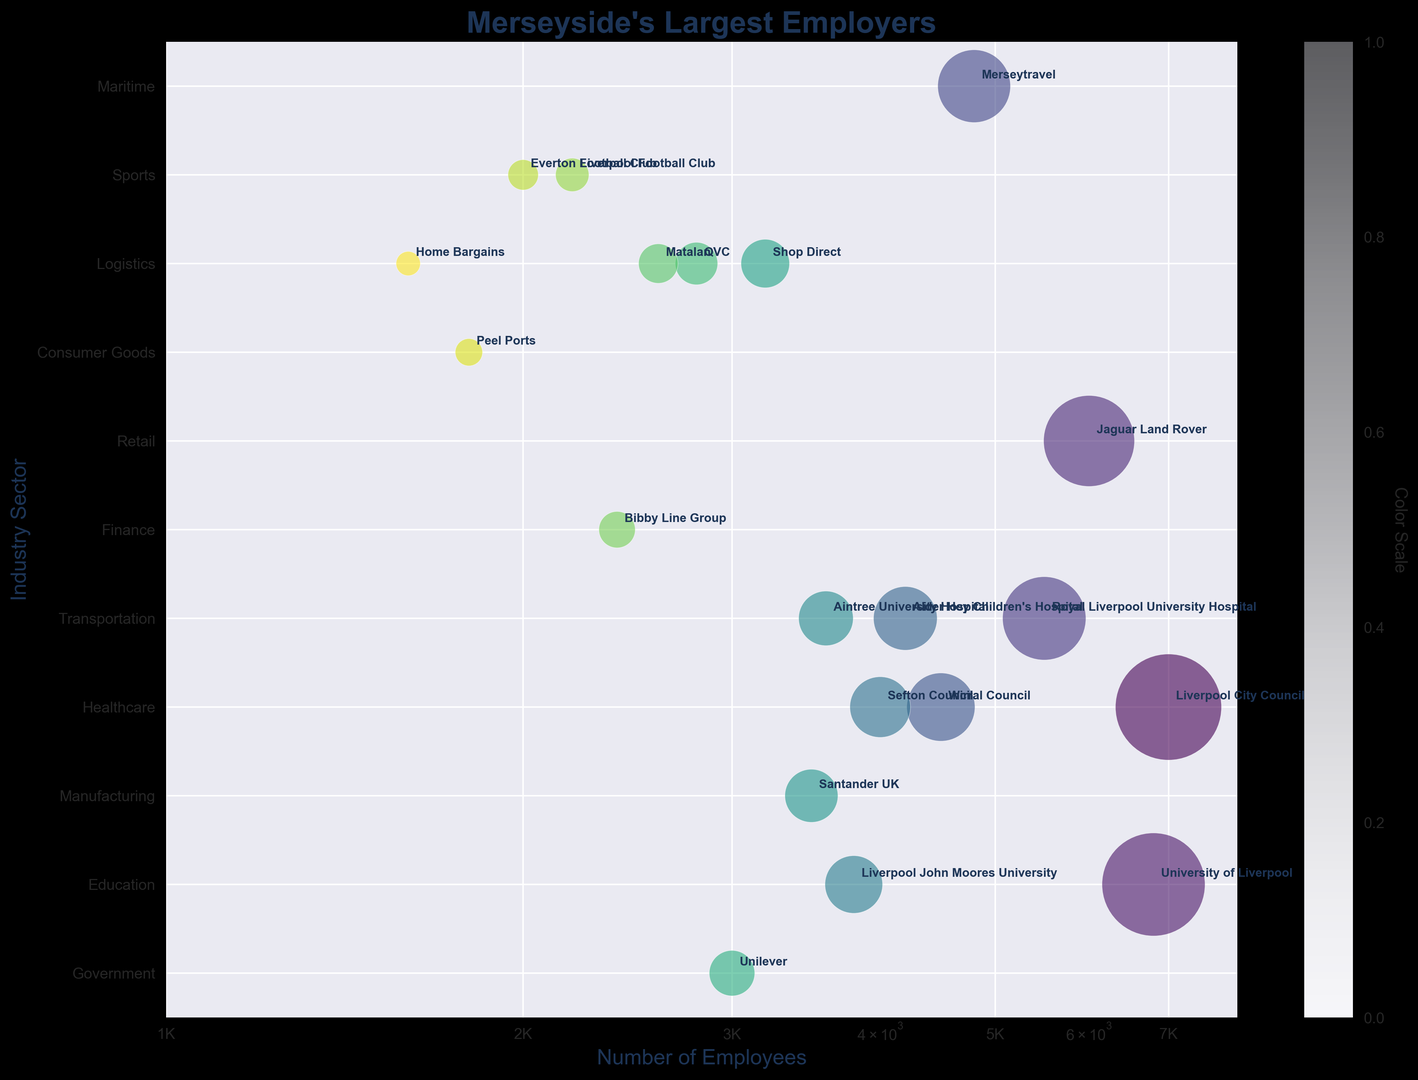Which employer has the largest bubble size on the chart? The bubble size corresponds to the number of employees. By looking at the largest bubble, which represents the most employees, we can see that Liverpool City Council has the largest bubble.
Answer: Liverpool City Council Which sector has the highest number of bubbles appearing in the chart? By counting the number of bubbles in each sector vertically along the y-axis, we can see that the sector with the most bubbles is the Retail sector.
Answer: Retail How many bubbles correspond to the Healthcare sector? Count the bubbles that fall on the y-axis label corresponding to Healthcare. There are three bubbles: Royal Liverpool University Hospital, Alder Hey Children's Hospital, and Aintree University Hospital.
Answer: 3 Which employer in the Government sector has the smallest number of employees? Within the Government sector, by comparing bubble sizes, Sefton Council has 4000 employees, which is the smallest compared to Liverpool City Council and Wirral Council.
Answer: Sefton Council What is the average number of employees for the Education sector? Sum the number of employees for University of Liverpool (6800) and Liverpool John Moores University (3800) and then divide by the 2 institutions. The calculation is (6800 + 3800) / 2 = 5300.
Answer: 5300 Compare the bubbles for Jaguar Land Rover and Royal Liverpool University Hospital. Which employer has more employees? By comparing the size of the two bubbles, Jaguar Land Rover has a larger bubble size representing 6000 employees while Royal Liverpool University Hospital has 5500 employees.
Answer: Jaguar Land Rover Between Liverpool Football Club and Everton Football Club, which has more employees, and by how much? Comparing the two bubbles, Liverpool FC (2200 employees) and Everton FC (2000 employees), Liverpool FC has more by 200 employees.
Answer: Liverpool FC, 200 What is the total number of employees in the Retail sector? Add the number of employees for all bubbles in the Retail sector: Shop Direct (3200), QVC (2800), Matalan (2600), Home Bargains (1600). So, 3200 + 2800 + 2600 + 1600 = 10200.
Answer: 10200 Which bubble has the darkest color and what does it represent? The darkest color in the plot correlates to the highest position in the color scale, typically indicating the earliest point of the gradient. The Royal Liverpool University Hospital appears to have the darkest color.
Answer: Royal Liverpool University Hospital What is the combined number of employees for the companies in the Transportation and Maritime sectors? Add the employees for Merseytravel (4800) in Transportation and Peel Ports (1800) in Maritime. The calculation is 4800 + 1800 = 6600.
Answer: 6600 